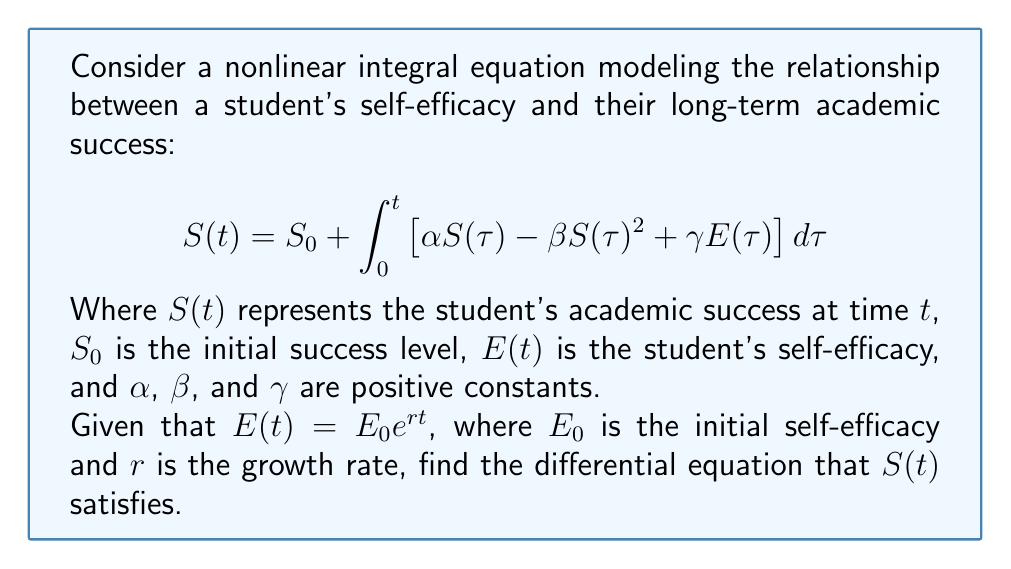Can you solve this math problem? To solve this problem, we'll follow these steps:

1) First, we recognize that the given equation is an integral equation for $S(t)$. To find the differential equation that $S(t)$ satisfies, we need to differentiate both sides with respect to $t$.

2) Let's start by differentiating the left side:

   $$\frac{d}{dt}S(t) = S'(t)$$

3) Now, let's differentiate the right side. We'll use the Fundamental Theorem of Calculus:

   $$\frac{d}{dt}\left(S_0 + \int_0^t \left[ \alpha S(\tau) - \beta S(\tau)^2 + \gamma E(\tau) \right] d\tau\right)$$
   
   $$= 0 + \alpha S(t) - \beta S(t)^2 + \gamma E(t)$$

4) Now we can equate the derivatives of both sides:

   $$S'(t) = \alpha S(t) - \beta S(t)^2 + \gamma E(t)$$

5) We're given that $E(t) = E_0 e^{rt}$, so let's substitute this:

   $$S'(t) = \alpha S(t) - \beta S(t)^2 + \gamma E_0 e^{rt}$$

This is the differential equation that $S(t)$ satisfies.
Answer: $$S'(t) = \alpha S(t) - \beta S(t)^2 + \gamma E_0 e^{rt}$$ 